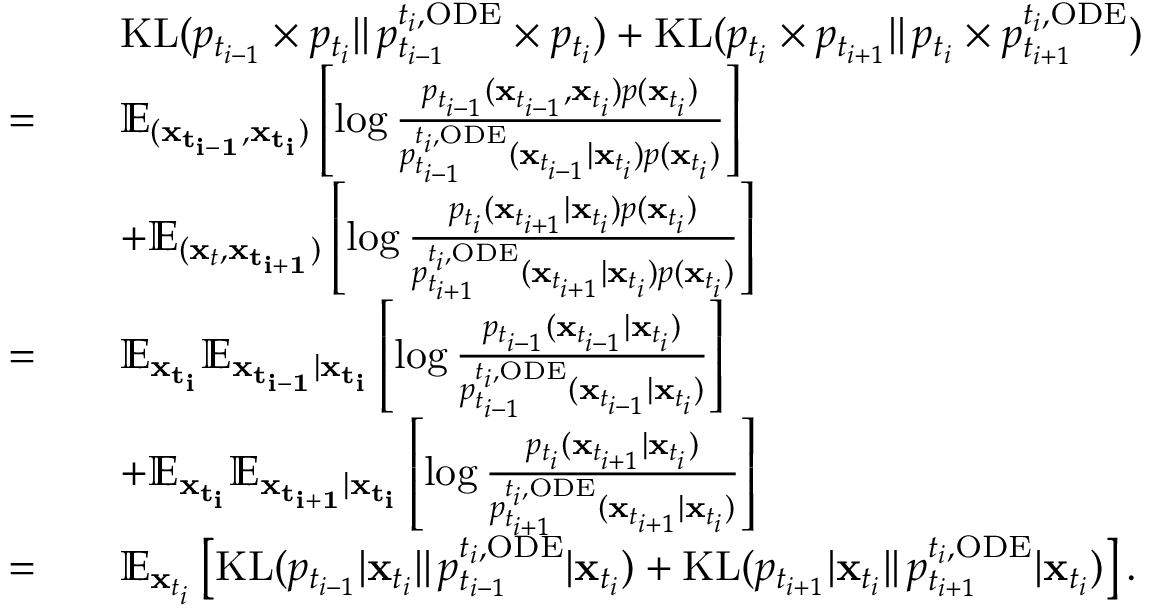Convert formula to latex. <formula><loc_0><loc_0><loc_500><loc_500>\begin{array} { r l } & { \quad K L ( p _ { t _ { i - 1 } } \times p _ { t _ { i } } | | \, p _ { t _ { i - 1 } } ^ { t _ { i } , O D E } \times p _ { t _ { i } } ) + K L ( p _ { t _ { i } } \times p _ { t _ { i + 1 } } | | \, p _ { t _ { i } } \times p _ { t _ { i + 1 } } ^ { t _ { i } , O D E } ) } \\ { = } & { \quad \mathbb { E } _ { ( x _ { t _ { i - 1 } } , x _ { t _ { i } } ) } \left [ \log \frac { p _ { t _ { i - 1 } } ( x _ { t _ { i - 1 } } , x _ { t _ { i } } ) p ( x _ { t _ { i } } ) } { p _ { t _ { i - 1 } } ^ { t _ { i } , O D E } ( x _ { t _ { i - 1 } } | x _ { t _ { i } } ) p ( x _ { t _ { i } } ) } \right ] } \\ & { \quad + \mathbb { E } _ { ( x _ { t } , x _ { t _ { i + 1 } } ) } \left [ \log \frac { p _ { t _ { i } } ( x _ { t _ { i + 1 } } | x _ { t _ { i } } ) p ( x _ { t _ { i } } ) } { p _ { t _ { i + 1 } } ^ { t _ { i } , O D E } ( x _ { t _ { i + 1 } } | x _ { t _ { i } } ) p ( x _ { t _ { i } } ) } \right ] } \\ { = } & { \quad \mathbb { E } _ { x _ { t _ { i } } } \mathbb { E } _ { x _ { t _ { i - 1 } } | x _ { t _ { i } } } \left [ \log \frac { p _ { t _ { i - 1 } } ( x _ { t _ { i - 1 } } | x _ { t _ { i } } ) } { p _ { t _ { i - 1 } } ^ { t _ { i } , O D E } ( x _ { t _ { i - 1 } } | x _ { t _ { i } } ) } \right ] } \\ & { \quad + \mathbb { E } _ { x _ { t _ { i } } } \mathbb { E } _ { x _ { t _ { i + 1 } } | x _ { t _ { i } } } \left [ \log \frac { p _ { t _ { i } } ( x _ { t _ { i + 1 } } | x _ { t _ { i } } ) } { p _ { t _ { i + 1 } } ^ { t _ { i } , O D E } ( x _ { t _ { i + 1 } } | x _ { t _ { i } } ) } \right ] } \\ { = } & { \quad \mathbb { E } _ { x _ { t _ { i } } } \left [ K L ( p _ { t _ { i - 1 } } | x _ { t _ { i } } | | \, p _ { t _ { i - 1 } } ^ { t _ { i } , O D E } | x _ { t _ { i } } ) + K L ( p _ { t _ { i + 1 } } | x _ { t _ { i } } | | \, p _ { t _ { i + 1 } } ^ { t _ { i } , O D E } | x _ { t _ { i } } ) \right ] . } \end{array}</formula> 